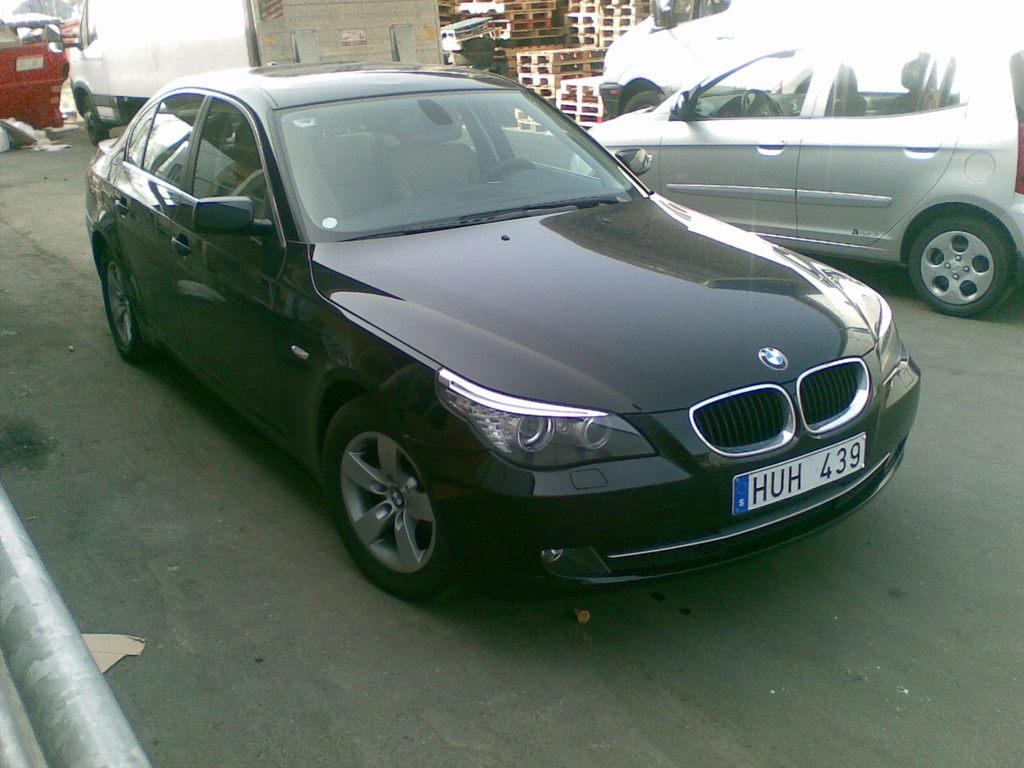What types of vehicles are present in the image? There are two cars on either side of the road and a truck in the image. Can you describe the positioning of the vehicles? The cars are on either side of the road, and the truck is beside them. What else can be seen near the truck? There are plastic trays beside the truck. What type of unit is being transported by the truck in the image? There is no indication of any unit being transported by the truck in the image. What message of hope can be seen on the side of the truck? There is no message of hope visible on the truck in the image. 